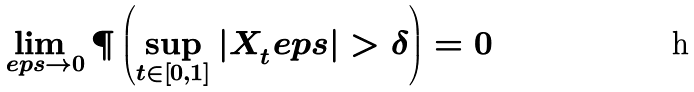<formula> <loc_0><loc_0><loc_500><loc_500>\lim _ { \ e p s \to 0 } \P \left ( \sup _ { t \in [ 0 , 1 ] } | X _ { t } ^ { \ } e p s | > \delta \right ) = 0</formula> 